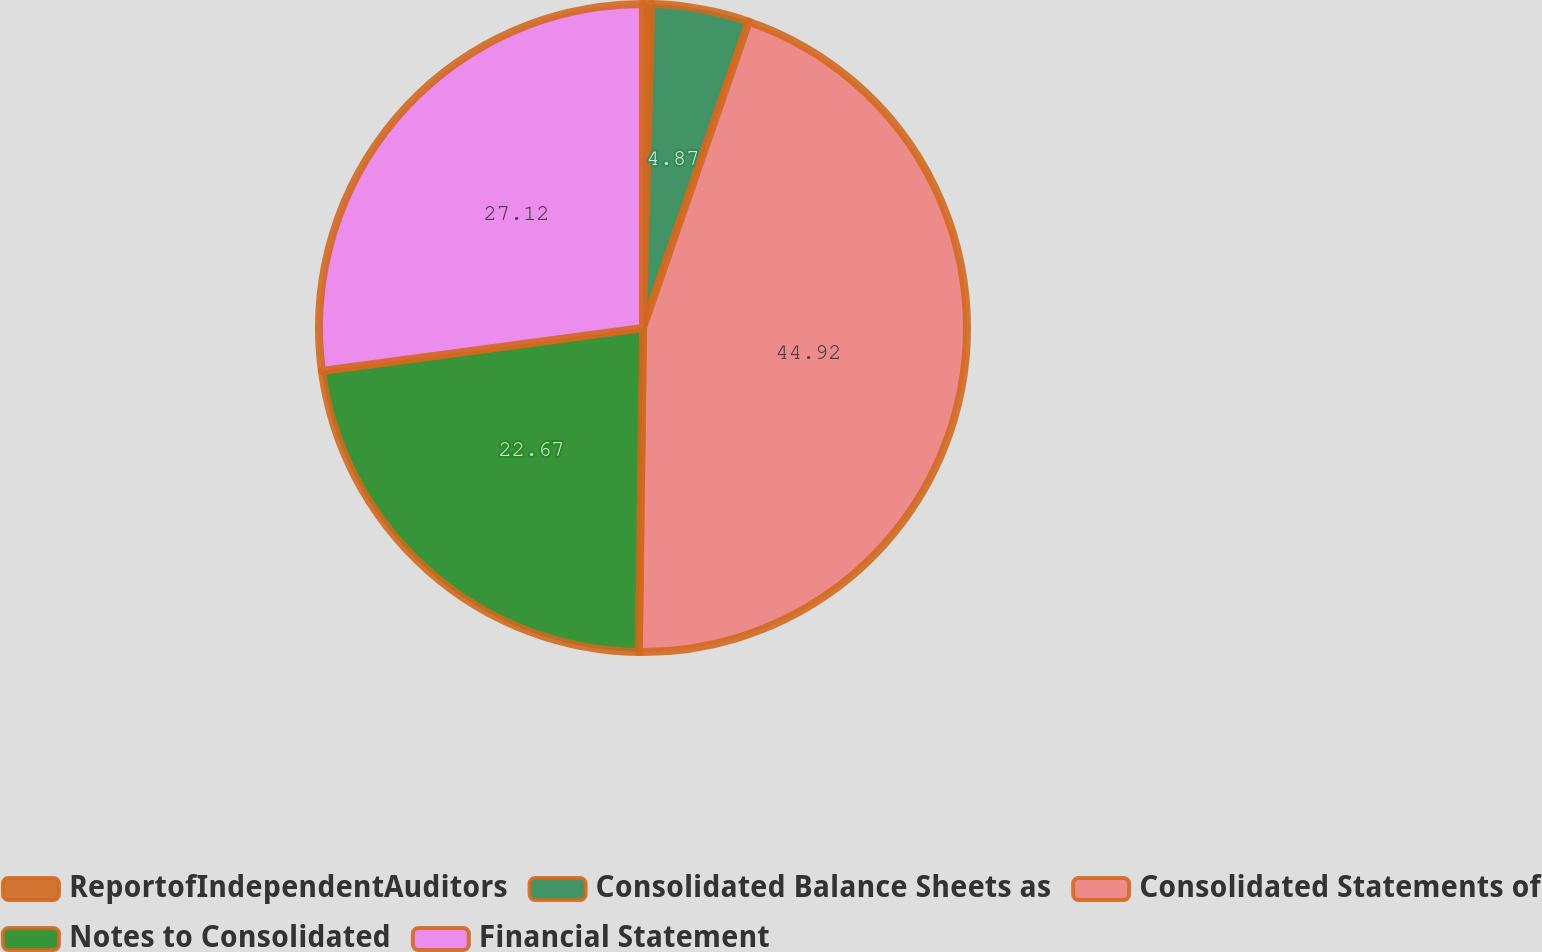Convert chart. <chart><loc_0><loc_0><loc_500><loc_500><pie_chart><fcel>ReportofIndependentAuditors<fcel>Consolidated Balance Sheets as<fcel>Consolidated Statements of<fcel>Notes to Consolidated<fcel>Financial Statement<nl><fcel>0.42%<fcel>4.87%<fcel>44.92%<fcel>22.67%<fcel>27.12%<nl></chart> 